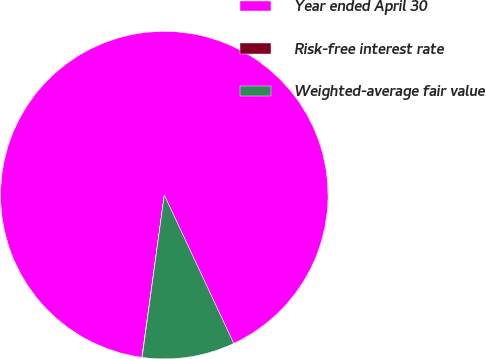Convert chart to OTSL. <chart><loc_0><loc_0><loc_500><loc_500><pie_chart><fcel>Year ended April 30<fcel>Risk-free interest rate<fcel>Weighted-average fair value<nl><fcel>90.85%<fcel>0.04%<fcel>9.12%<nl></chart> 